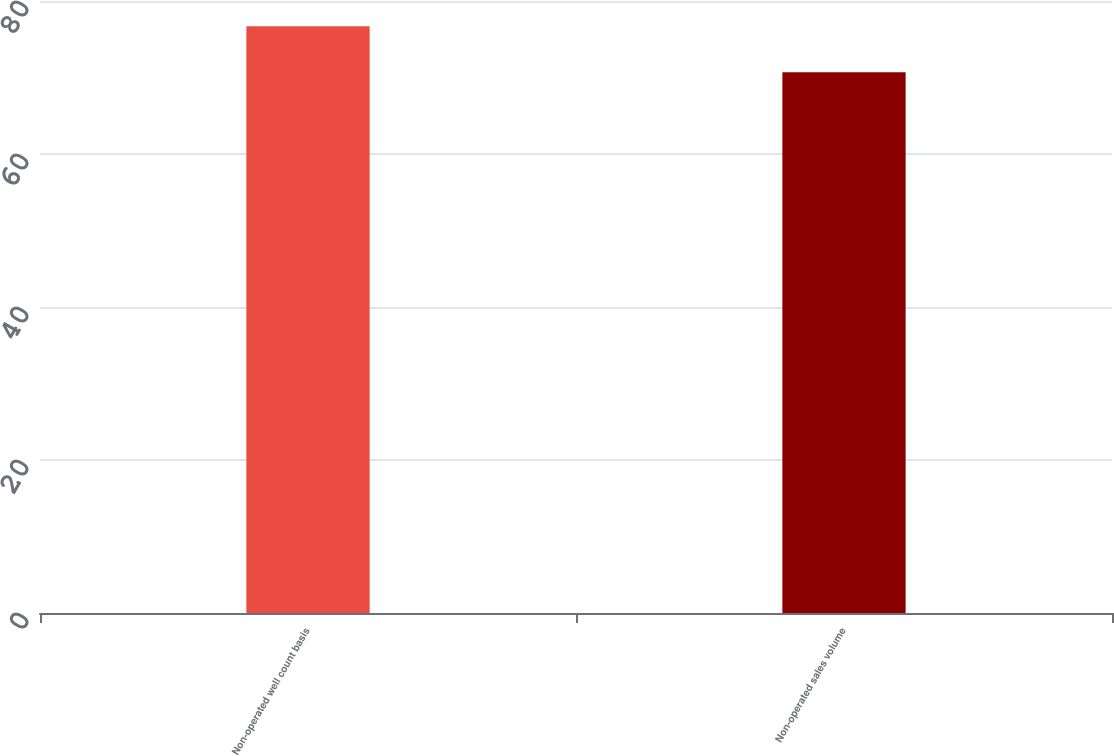Convert chart to OTSL. <chart><loc_0><loc_0><loc_500><loc_500><bar_chart><fcel>Non-operated well count basis<fcel>Non-operated sales volume<nl><fcel>76.7<fcel>70.7<nl></chart> 